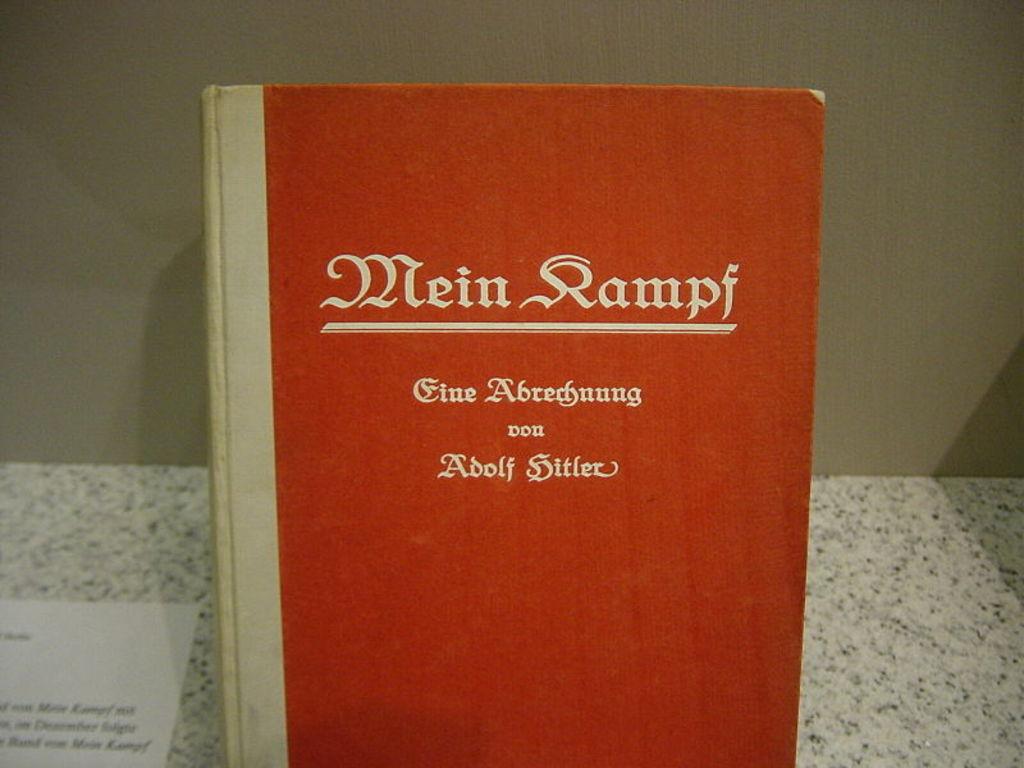What is the name of this book?
Make the answer very short. Mein kampf. Who wrote this book?
Make the answer very short. Adolf hitler. 